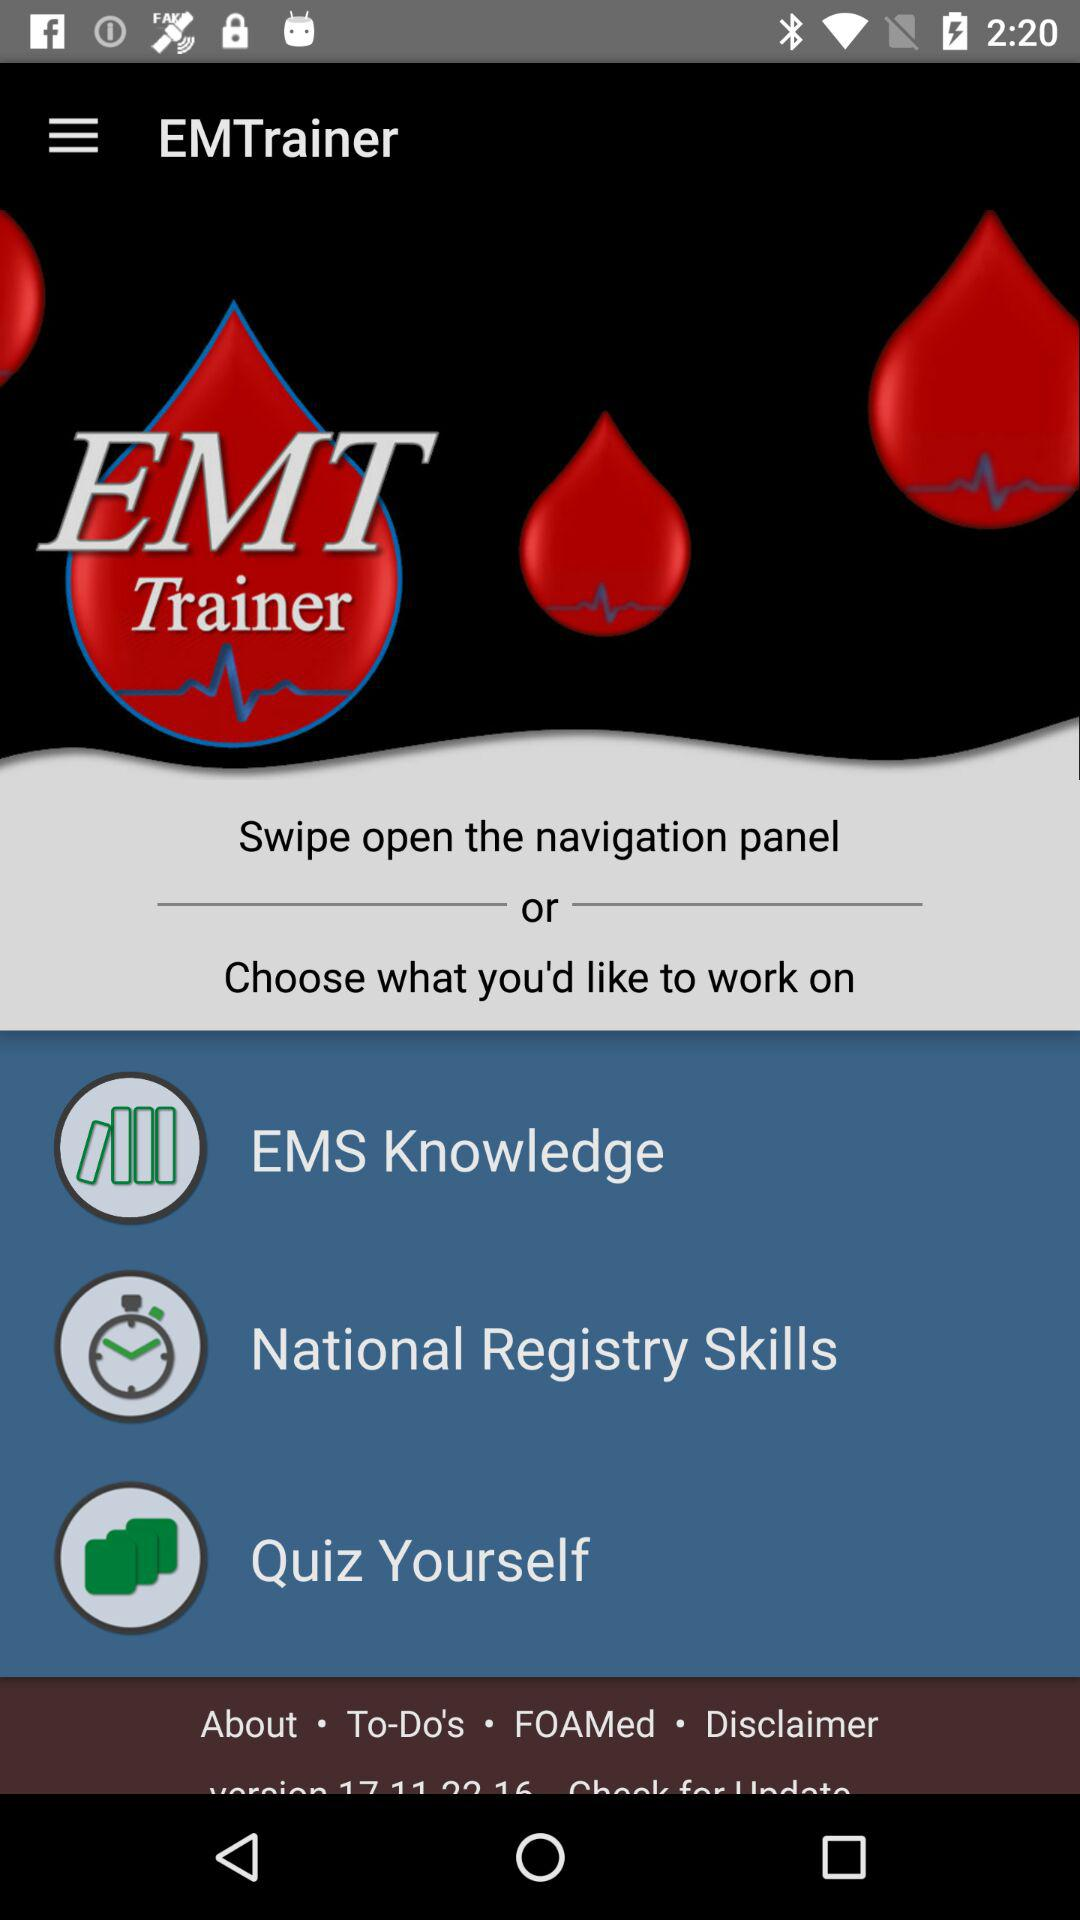What is the name of the application? The name of the application is "EMTrainer". 